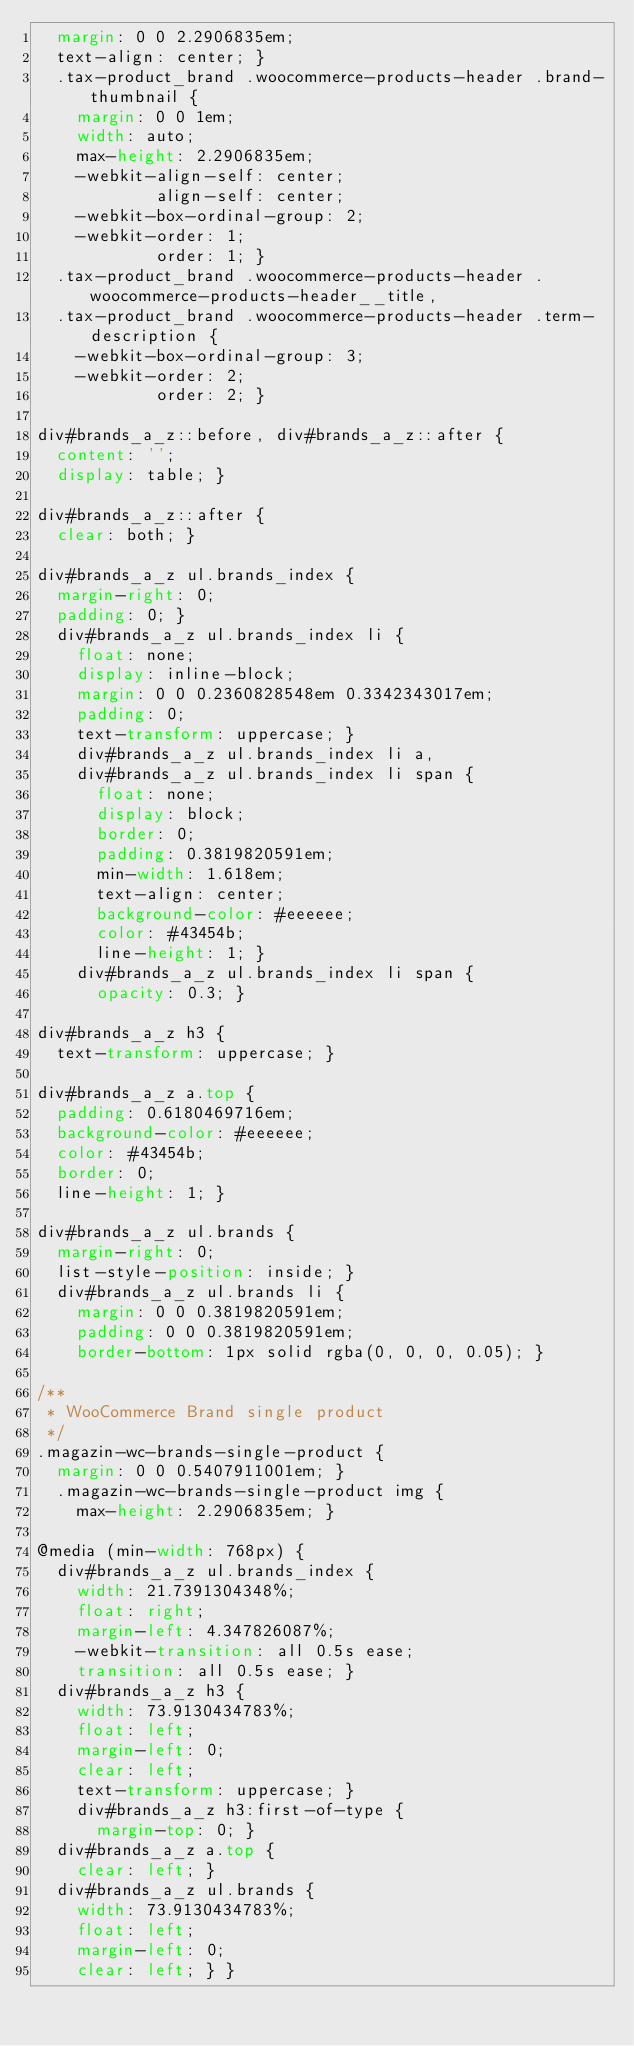Convert code to text. <code><loc_0><loc_0><loc_500><loc_500><_CSS_>  margin: 0 0 2.2906835em;
  text-align: center; }
  .tax-product_brand .woocommerce-products-header .brand-thumbnail {
    margin: 0 0 1em;
    width: auto;
    max-height: 2.2906835em;
    -webkit-align-self: center;
            align-self: center;
    -webkit-box-ordinal-group: 2;
    -webkit-order: 1;
            order: 1; }
  .tax-product_brand .woocommerce-products-header .woocommerce-products-header__title,
  .tax-product_brand .woocommerce-products-header .term-description {
    -webkit-box-ordinal-group: 3;
    -webkit-order: 2;
            order: 2; }

div#brands_a_z::before, div#brands_a_z::after {
  content: '';
  display: table; }

div#brands_a_z::after {
  clear: both; }

div#brands_a_z ul.brands_index {
  margin-right: 0;
  padding: 0; }
  div#brands_a_z ul.brands_index li {
    float: none;
    display: inline-block;
    margin: 0 0 0.2360828548em 0.3342343017em;
    padding: 0;
    text-transform: uppercase; }
    div#brands_a_z ul.brands_index li a,
    div#brands_a_z ul.brands_index li span {
      float: none;
      display: block;
      border: 0;
      padding: 0.3819820591em;
      min-width: 1.618em;
      text-align: center;
      background-color: #eeeeee;
      color: #43454b;
      line-height: 1; }
    div#brands_a_z ul.brands_index li span {
      opacity: 0.3; }

div#brands_a_z h3 {
  text-transform: uppercase; }

div#brands_a_z a.top {
  padding: 0.6180469716em;
  background-color: #eeeeee;
  color: #43454b;
  border: 0;
  line-height: 1; }

div#brands_a_z ul.brands {
  margin-right: 0;
  list-style-position: inside; }
  div#brands_a_z ul.brands li {
    margin: 0 0 0.3819820591em;
    padding: 0 0 0.3819820591em;
    border-bottom: 1px solid rgba(0, 0, 0, 0.05); }

/**
 * WooCommerce Brand single product
 */
.magazin-wc-brands-single-product {
  margin: 0 0 0.5407911001em; }
  .magazin-wc-brands-single-product img {
    max-height: 2.2906835em; }

@media (min-width: 768px) {
  div#brands_a_z ul.brands_index {
    width: 21.7391304348%;
    float: right;
    margin-left: 4.347826087%;
    -webkit-transition: all 0.5s ease;
    transition: all 0.5s ease; }
  div#brands_a_z h3 {
    width: 73.9130434783%;
    float: left;
    margin-left: 0;
    clear: left;
    text-transform: uppercase; }
    div#brands_a_z h3:first-of-type {
      margin-top: 0; }
  div#brands_a_z a.top {
    clear: left; }
  div#brands_a_z ul.brands {
    width: 73.9130434783%;
    float: left;
    margin-left: 0;
    clear: left; } }
</code> 